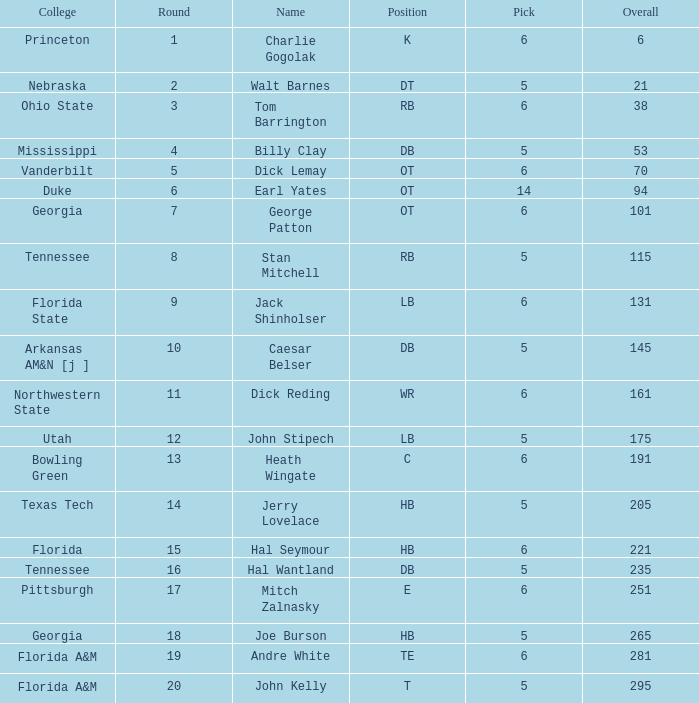What is the sum of Overall, when Pick is greater than 5, when Round is less than 11, and when Name is "Tom Barrington"? 38.0. 